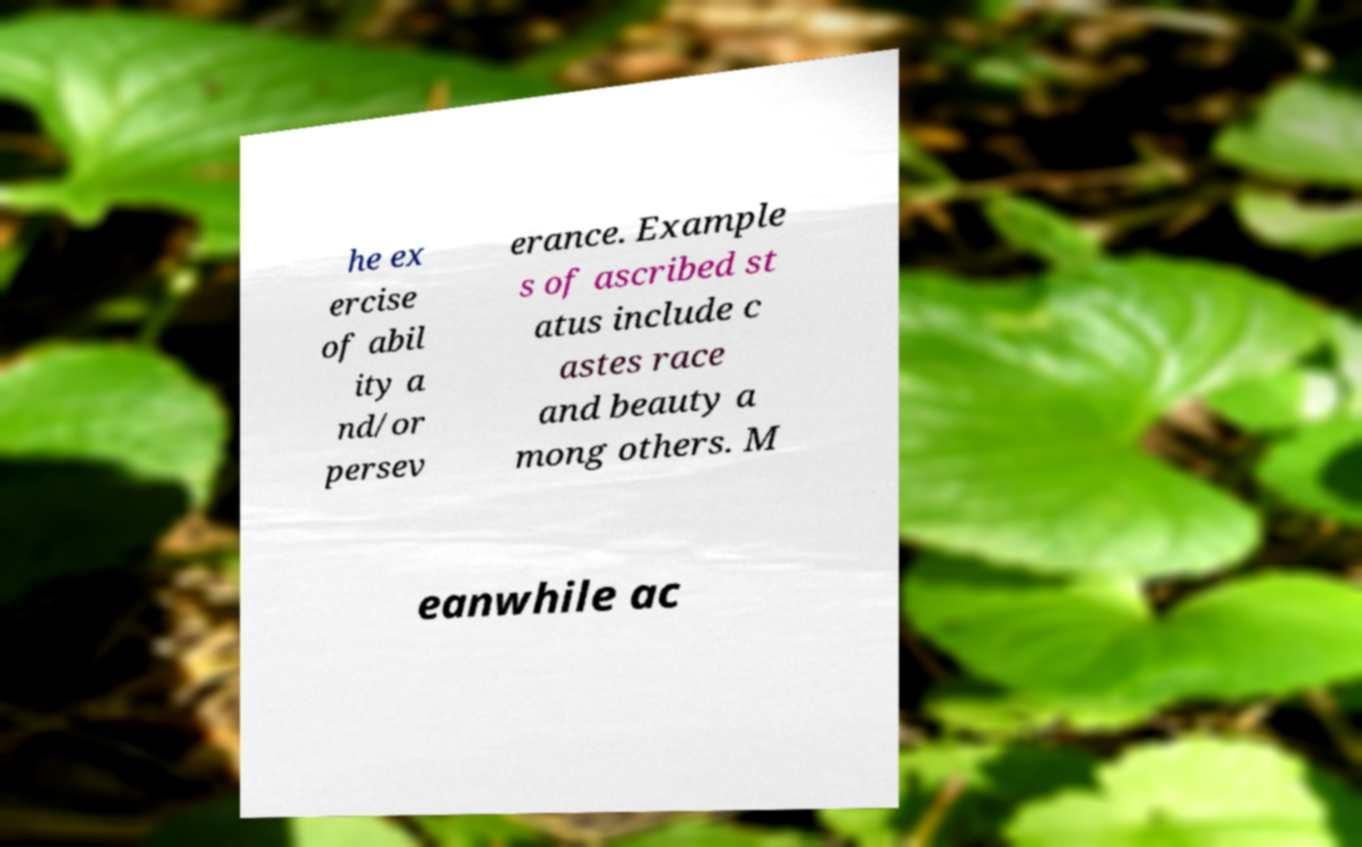Please identify and transcribe the text found in this image. he ex ercise of abil ity a nd/or persev erance. Example s of ascribed st atus include c astes race and beauty a mong others. M eanwhile ac 